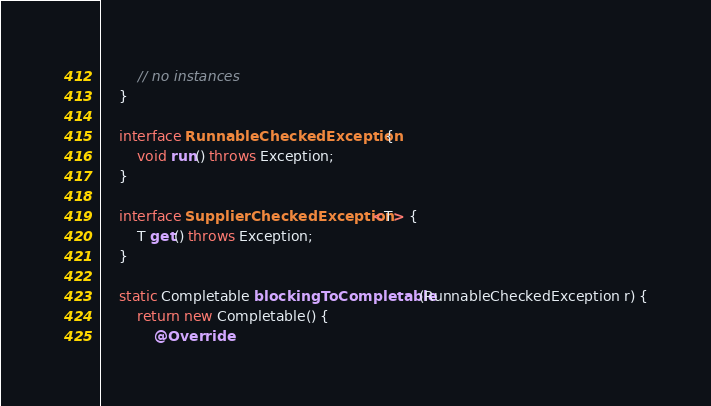<code> <loc_0><loc_0><loc_500><loc_500><_Java_>        // no instances
    }

    interface RunnableCheckedException {
        void run() throws Exception;
    }

    interface SupplierCheckedException<T> {
        T get() throws Exception;
    }

    static Completable blockingToCompletable(RunnableCheckedException r) {
        return new Completable() {
            @Override</code> 